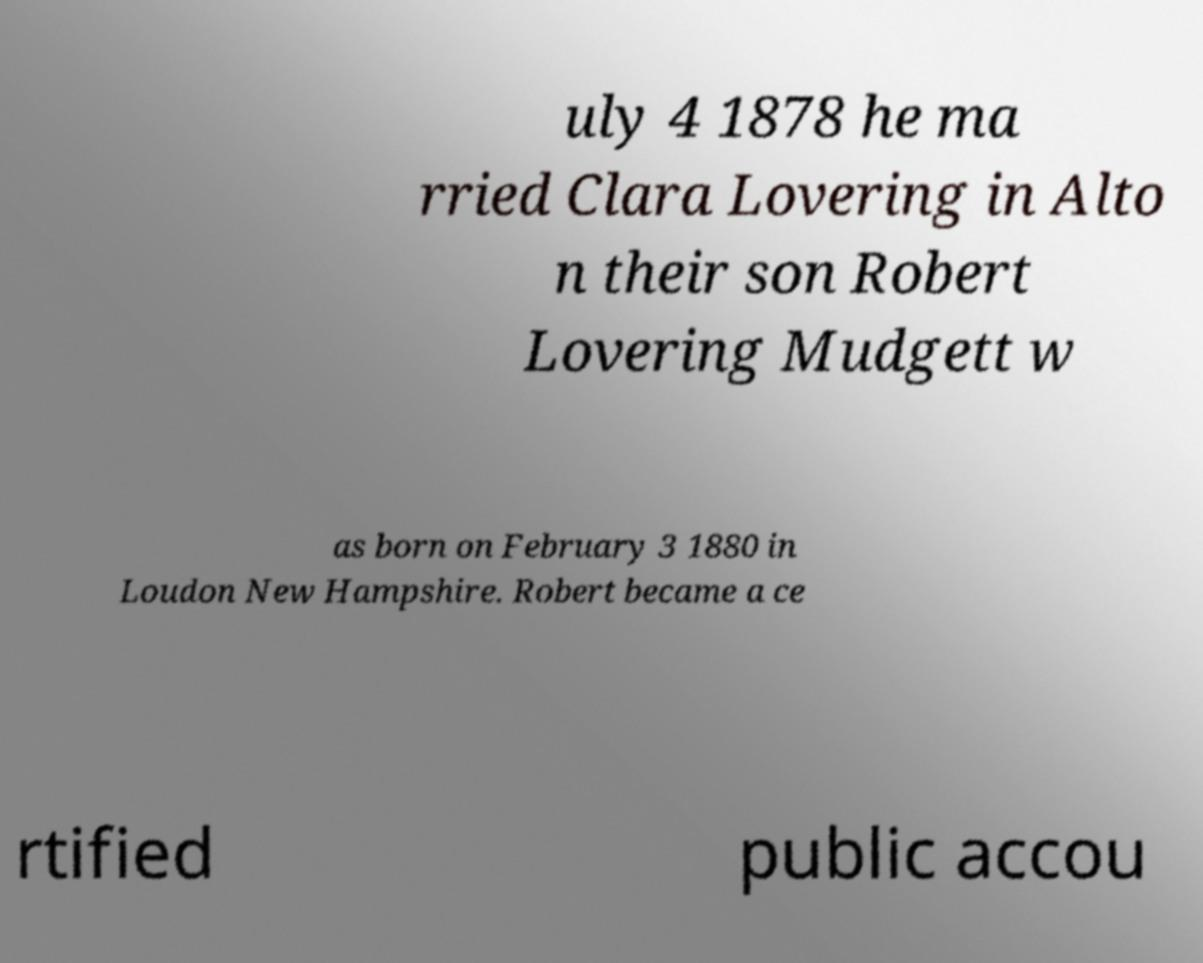Please identify and transcribe the text found in this image. uly 4 1878 he ma rried Clara Lovering in Alto n their son Robert Lovering Mudgett w as born on February 3 1880 in Loudon New Hampshire. Robert became a ce rtified public accou 